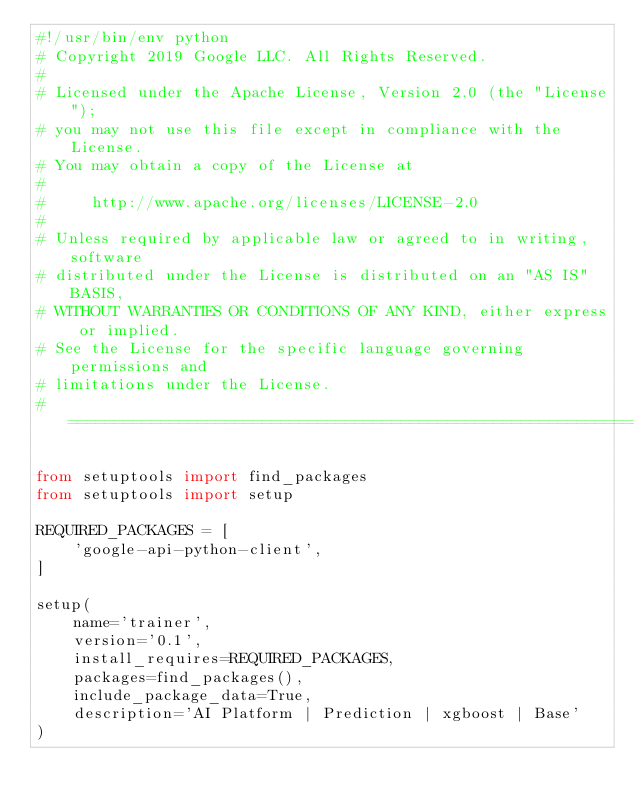Convert code to text. <code><loc_0><loc_0><loc_500><loc_500><_Python_>#!/usr/bin/env python
# Copyright 2019 Google LLC. All Rights Reserved.
#
# Licensed under the Apache License, Version 2.0 (the "License");
# you may not use this file except in compliance with the License.
# You may obtain a copy of the License at
#
#     http://www.apache.org/licenses/LICENSE-2.0
#
# Unless required by applicable law or agreed to in writing, software
# distributed under the License is distributed on an "AS IS" BASIS,
# WITHOUT WARRANTIES OR CONDITIONS OF ANY KIND, either express or implied.
# See the License for the specific language governing permissions and
# limitations under the License.
# ==============================================================================

from setuptools import find_packages
from setuptools import setup

REQUIRED_PACKAGES = [
    'google-api-python-client',
]

setup(
    name='trainer',
    version='0.1',
    install_requires=REQUIRED_PACKAGES,
    packages=find_packages(),
    include_package_data=True,
    description='AI Platform | Prediction | xgboost | Base'
)</code> 